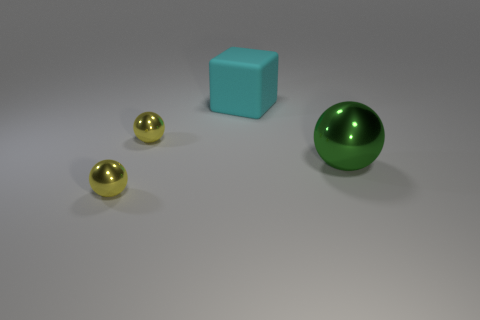Can you describe the texture of the objects? Certainly, the blue cube appears to have a matte texture, which diffuses light and gives it a soft appearance. The green sphere and the two golden spheres have shiny surfaces, suggesting a smooth and possibly metallic texture that results in more defined reflections. 